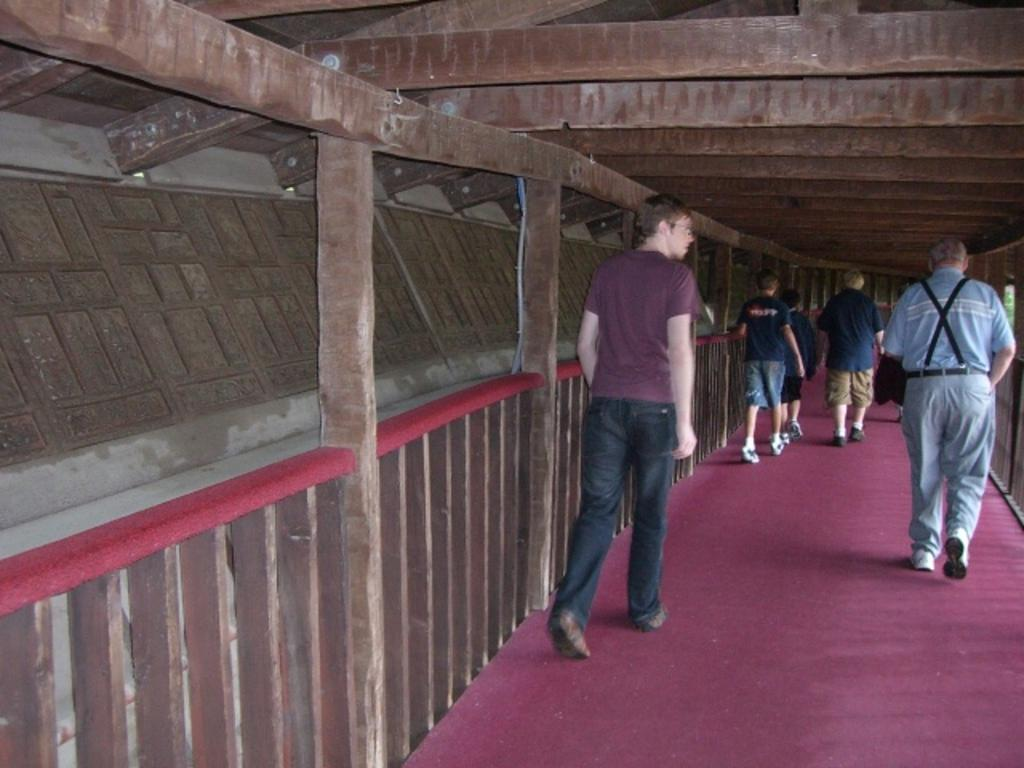What are the people in the image doing? There are persons walking in the image. What can be seen under the people's feet? The floor is visible in the image. What type of fencing is on the left side of the image? There is wooden fencing on the left side of the image. What structure is present above the people in the image? A roof is present in the image. How many sheep are visible in the image? There are no sheep present in the image. What season is depicted in the image based on the colors of the leaves on the trees? The image does not show any trees or leaves, so it is not possible to determine the season. 